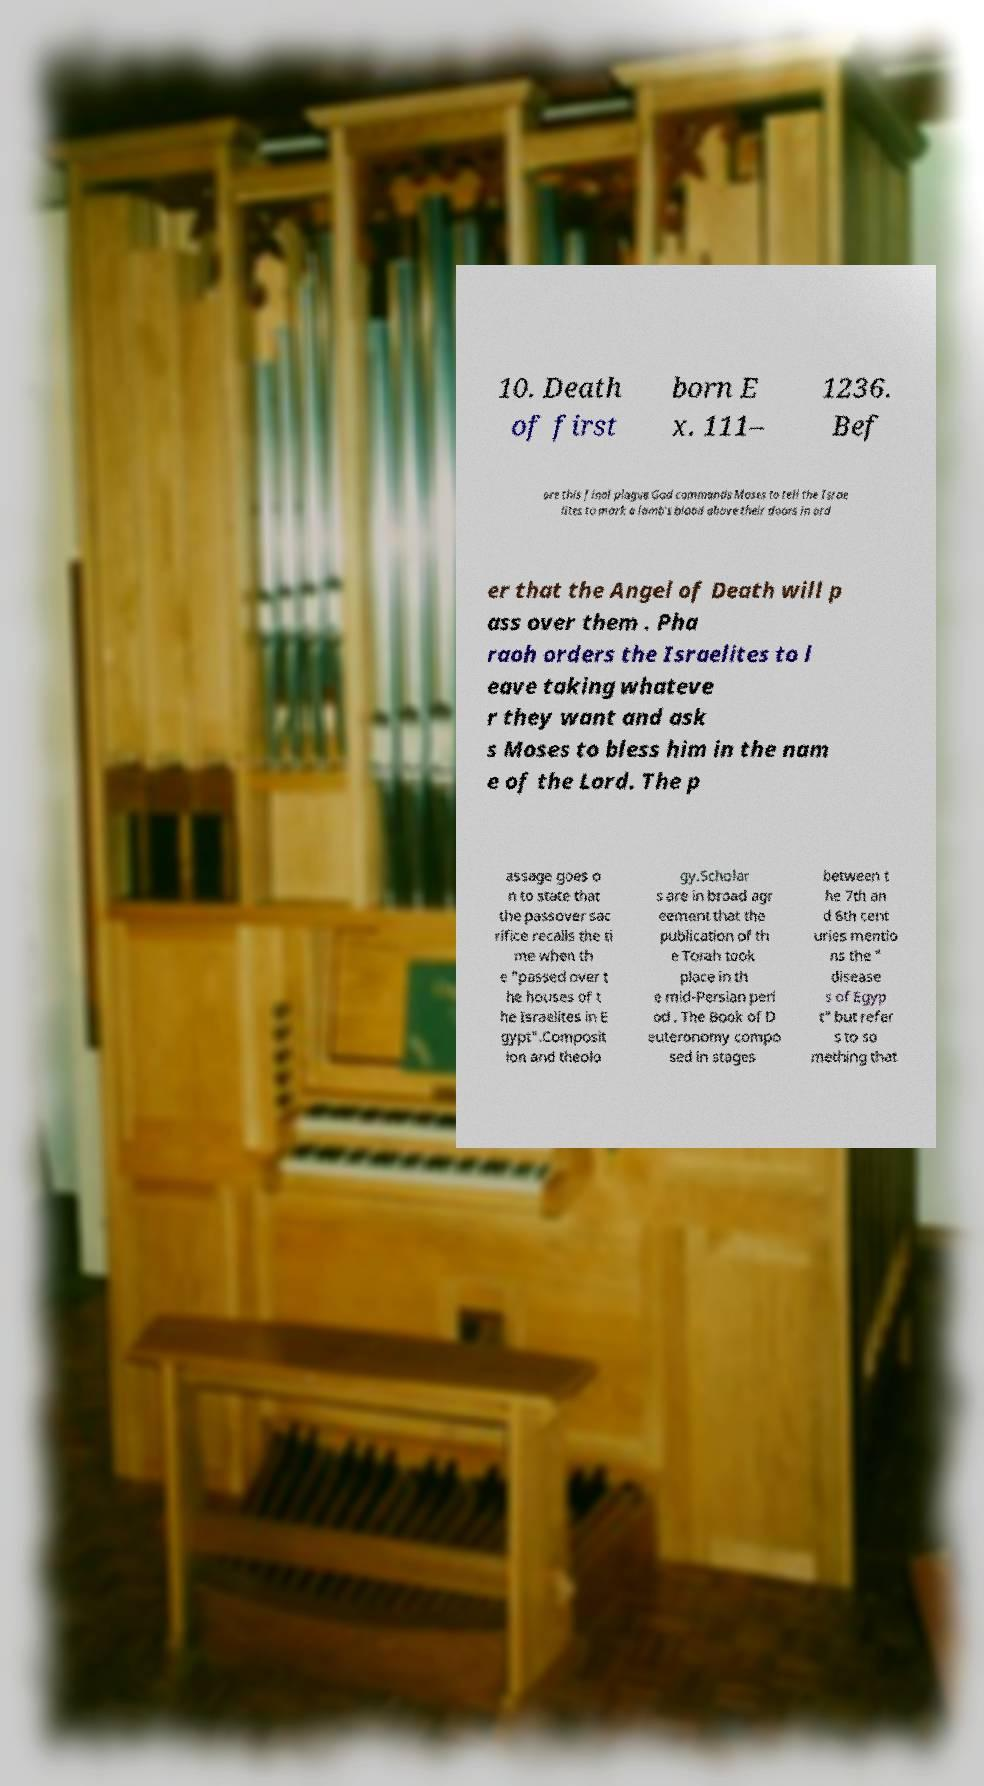Can you read and provide the text displayed in the image?This photo seems to have some interesting text. Can you extract and type it out for me? 10. Death of first born E x. 111– 1236. Bef ore this final plague God commands Moses to tell the Israe lites to mark a lamb's blood above their doors in ord er that the Angel of Death will p ass over them . Pha raoh orders the Israelites to l eave taking whateve r they want and ask s Moses to bless him in the nam e of the Lord. The p assage goes o n to state that the passover sac rifice recalls the ti me when th e "passed over t he houses of t he Israelites in E gypt".Composit ion and theolo gy.Scholar s are in broad agr eement that the publication of th e Torah took place in th e mid-Persian peri od . The Book of D euteronomy compo sed in stages between t he 7th an d 6th cent uries mentio ns the " disease s of Egyp t" but refer s to so mething that 